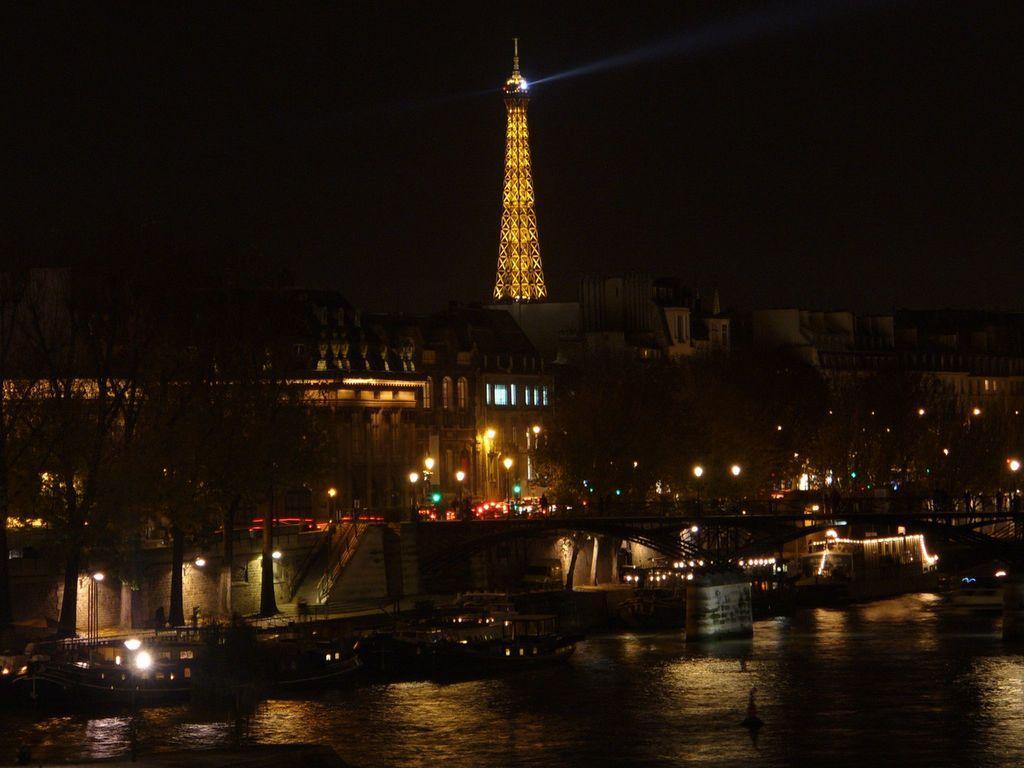In one or two sentences, can you explain what this image depicts? In this image I can see few boats on the water. To the side of the water I can see many trees. In the background I can see the buildings, lights and the tower. I can see the black background. 